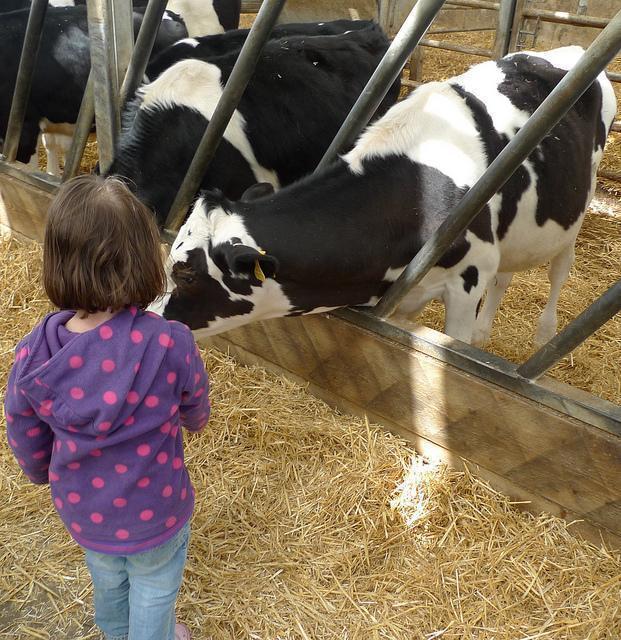What design is on the little girl's hoodie?
Select the accurate answer and provide justification: `Answer: choice
Rationale: srationale.`
Options: Stripes, polka dots, medusa heads, stars. Answer: polka dots.
Rationale: There is a little girl with purple jacket and small pink circles dotted all over it. she is feeding the cows. What is near the cows?
Select the correct answer and articulate reasoning with the following format: 'Answer: answer
Rationale: rationale.'
Options: Cat, bodybuilder, little girl, apple. Answer: little girl.
Rationale: A female person is near the cows. she is not an adult. 